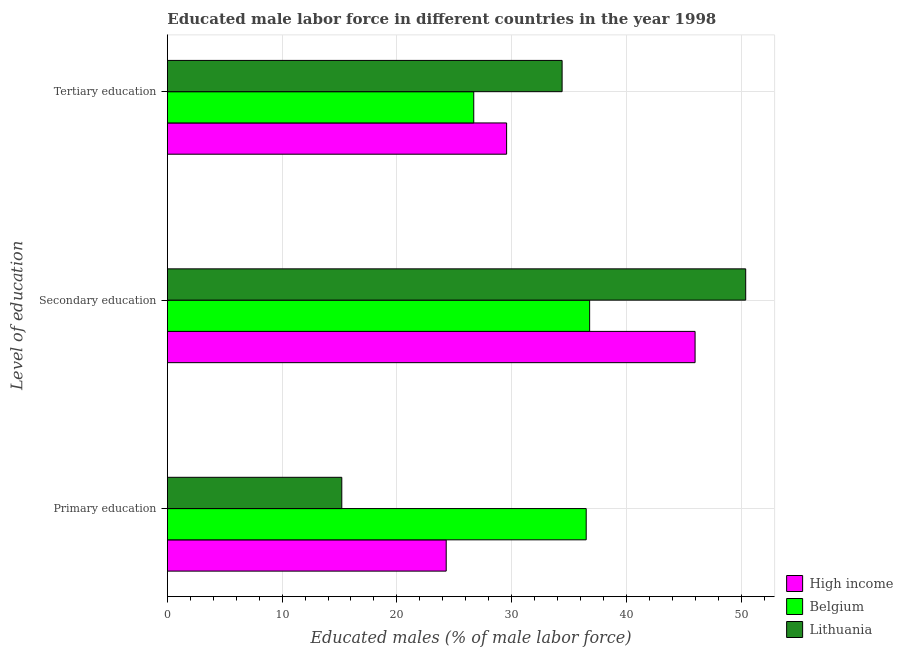Are the number of bars on each tick of the Y-axis equal?
Make the answer very short. Yes. How many bars are there on the 1st tick from the top?
Your answer should be very brief. 3. What is the label of the 2nd group of bars from the top?
Your response must be concise. Secondary education. What is the percentage of male labor force who received primary education in Lithuania?
Give a very brief answer. 15.2. Across all countries, what is the maximum percentage of male labor force who received primary education?
Your answer should be very brief. 36.5. Across all countries, what is the minimum percentage of male labor force who received tertiary education?
Give a very brief answer. 26.7. In which country was the percentage of male labor force who received primary education minimum?
Provide a succinct answer. Lithuania. What is the total percentage of male labor force who received tertiary education in the graph?
Your answer should be compact. 90.66. What is the difference between the percentage of male labor force who received tertiary education in High income and that in Belgium?
Make the answer very short. 2.86. What is the difference between the percentage of male labor force who received tertiary education in Lithuania and the percentage of male labor force who received primary education in Belgium?
Make the answer very short. -2.1. What is the average percentage of male labor force who received tertiary education per country?
Offer a very short reply. 30.22. What is the difference between the percentage of male labor force who received secondary education and percentage of male labor force who received tertiary education in High income?
Your response must be concise. 16.43. In how many countries, is the percentage of male labor force who received secondary education greater than 22 %?
Your answer should be compact. 3. What is the ratio of the percentage of male labor force who received secondary education in Belgium to that in Lithuania?
Give a very brief answer. 0.73. Is the percentage of male labor force who received primary education in High income less than that in Lithuania?
Your answer should be compact. No. Is the difference between the percentage of male labor force who received secondary education in Lithuania and Belgium greater than the difference between the percentage of male labor force who received tertiary education in Lithuania and Belgium?
Provide a succinct answer. Yes. What is the difference between the highest and the second highest percentage of male labor force who received primary education?
Make the answer very short. 12.2. What is the difference between the highest and the lowest percentage of male labor force who received tertiary education?
Keep it short and to the point. 7.7. Is the sum of the percentage of male labor force who received secondary education in Lithuania and High income greater than the maximum percentage of male labor force who received tertiary education across all countries?
Your response must be concise. Yes. What does the 1st bar from the top in Primary education represents?
Make the answer very short. Lithuania. What does the 2nd bar from the bottom in Tertiary education represents?
Your response must be concise. Belgium. Are all the bars in the graph horizontal?
Give a very brief answer. Yes. How many countries are there in the graph?
Give a very brief answer. 3. What is the difference between two consecutive major ticks on the X-axis?
Provide a short and direct response. 10. How many legend labels are there?
Ensure brevity in your answer.  3. What is the title of the graph?
Keep it short and to the point. Educated male labor force in different countries in the year 1998. Does "Russian Federation" appear as one of the legend labels in the graph?
Give a very brief answer. No. What is the label or title of the X-axis?
Your answer should be very brief. Educated males (% of male labor force). What is the label or title of the Y-axis?
Provide a succinct answer. Level of education. What is the Educated males (% of male labor force) of High income in Primary education?
Provide a short and direct response. 24.3. What is the Educated males (% of male labor force) of Belgium in Primary education?
Your response must be concise. 36.5. What is the Educated males (% of male labor force) in Lithuania in Primary education?
Your answer should be very brief. 15.2. What is the Educated males (% of male labor force) in High income in Secondary education?
Give a very brief answer. 45.99. What is the Educated males (% of male labor force) of Belgium in Secondary education?
Make the answer very short. 36.8. What is the Educated males (% of male labor force) of Lithuania in Secondary education?
Offer a very short reply. 50.4. What is the Educated males (% of male labor force) of High income in Tertiary education?
Offer a very short reply. 29.56. What is the Educated males (% of male labor force) of Belgium in Tertiary education?
Keep it short and to the point. 26.7. What is the Educated males (% of male labor force) of Lithuania in Tertiary education?
Your answer should be very brief. 34.4. Across all Level of education, what is the maximum Educated males (% of male labor force) in High income?
Your response must be concise. 45.99. Across all Level of education, what is the maximum Educated males (% of male labor force) of Belgium?
Make the answer very short. 36.8. Across all Level of education, what is the maximum Educated males (% of male labor force) of Lithuania?
Ensure brevity in your answer.  50.4. Across all Level of education, what is the minimum Educated males (% of male labor force) of High income?
Your response must be concise. 24.3. Across all Level of education, what is the minimum Educated males (% of male labor force) of Belgium?
Provide a short and direct response. 26.7. Across all Level of education, what is the minimum Educated males (% of male labor force) of Lithuania?
Provide a short and direct response. 15.2. What is the total Educated males (% of male labor force) in High income in the graph?
Give a very brief answer. 99.85. What is the difference between the Educated males (% of male labor force) of High income in Primary education and that in Secondary education?
Keep it short and to the point. -21.69. What is the difference between the Educated males (% of male labor force) in Belgium in Primary education and that in Secondary education?
Make the answer very short. -0.3. What is the difference between the Educated males (% of male labor force) in Lithuania in Primary education and that in Secondary education?
Your answer should be compact. -35.2. What is the difference between the Educated males (% of male labor force) of High income in Primary education and that in Tertiary education?
Offer a terse response. -5.26. What is the difference between the Educated males (% of male labor force) of Belgium in Primary education and that in Tertiary education?
Your response must be concise. 9.8. What is the difference between the Educated males (% of male labor force) in Lithuania in Primary education and that in Tertiary education?
Your answer should be compact. -19.2. What is the difference between the Educated males (% of male labor force) of High income in Secondary education and that in Tertiary education?
Your answer should be compact. 16.43. What is the difference between the Educated males (% of male labor force) in Belgium in Secondary education and that in Tertiary education?
Provide a short and direct response. 10.1. What is the difference between the Educated males (% of male labor force) of Lithuania in Secondary education and that in Tertiary education?
Your answer should be compact. 16. What is the difference between the Educated males (% of male labor force) in High income in Primary education and the Educated males (% of male labor force) in Belgium in Secondary education?
Offer a very short reply. -12.5. What is the difference between the Educated males (% of male labor force) in High income in Primary education and the Educated males (% of male labor force) in Lithuania in Secondary education?
Offer a terse response. -26.1. What is the difference between the Educated males (% of male labor force) of High income in Primary education and the Educated males (% of male labor force) of Belgium in Tertiary education?
Provide a short and direct response. -2.4. What is the difference between the Educated males (% of male labor force) in High income in Primary education and the Educated males (% of male labor force) in Lithuania in Tertiary education?
Ensure brevity in your answer.  -10.1. What is the difference between the Educated males (% of male labor force) of Belgium in Primary education and the Educated males (% of male labor force) of Lithuania in Tertiary education?
Give a very brief answer. 2.1. What is the difference between the Educated males (% of male labor force) of High income in Secondary education and the Educated males (% of male labor force) of Belgium in Tertiary education?
Offer a very short reply. 19.29. What is the difference between the Educated males (% of male labor force) in High income in Secondary education and the Educated males (% of male labor force) in Lithuania in Tertiary education?
Your response must be concise. 11.59. What is the difference between the Educated males (% of male labor force) in Belgium in Secondary education and the Educated males (% of male labor force) in Lithuania in Tertiary education?
Make the answer very short. 2.4. What is the average Educated males (% of male labor force) in High income per Level of education?
Give a very brief answer. 33.28. What is the average Educated males (% of male labor force) in Belgium per Level of education?
Your answer should be very brief. 33.33. What is the average Educated males (% of male labor force) in Lithuania per Level of education?
Offer a terse response. 33.33. What is the difference between the Educated males (% of male labor force) of High income and Educated males (% of male labor force) of Belgium in Primary education?
Keep it short and to the point. -12.2. What is the difference between the Educated males (% of male labor force) in High income and Educated males (% of male labor force) in Lithuania in Primary education?
Provide a succinct answer. 9.1. What is the difference between the Educated males (% of male labor force) in Belgium and Educated males (% of male labor force) in Lithuania in Primary education?
Offer a very short reply. 21.3. What is the difference between the Educated males (% of male labor force) in High income and Educated males (% of male labor force) in Belgium in Secondary education?
Ensure brevity in your answer.  9.19. What is the difference between the Educated males (% of male labor force) in High income and Educated males (% of male labor force) in Lithuania in Secondary education?
Keep it short and to the point. -4.41. What is the difference between the Educated males (% of male labor force) of Belgium and Educated males (% of male labor force) of Lithuania in Secondary education?
Make the answer very short. -13.6. What is the difference between the Educated males (% of male labor force) in High income and Educated males (% of male labor force) in Belgium in Tertiary education?
Offer a terse response. 2.86. What is the difference between the Educated males (% of male labor force) in High income and Educated males (% of male labor force) in Lithuania in Tertiary education?
Provide a short and direct response. -4.84. What is the difference between the Educated males (% of male labor force) in Belgium and Educated males (% of male labor force) in Lithuania in Tertiary education?
Offer a terse response. -7.7. What is the ratio of the Educated males (% of male labor force) in High income in Primary education to that in Secondary education?
Provide a short and direct response. 0.53. What is the ratio of the Educated males (% of male labor force) in Belgium in Primary education to that in Secondary education?
Ensure brevity in your answer.  0.99. What is the ratio of the Educated males (% of male labor force) in Lithuania in Primary education to that in Secondary education?
Offer a very short reply. 0.3. What is the ratio of the Educated males (% of male labor force) of High income in Primary education to that in Tertiary education?
Offer a terse response. 0.82. What is the ratio of the Educated males (% of male labor force) in Belgium in Primary education to that in Tertiary education?
Your answer should be very brief. 1.37. What is the ratio of the Educated males (% of male labor force) of Lithuania in Primary education to that in Tertiary education?
Provide a short and direct response. 0.44. What is the ratio of the Educated males (% of male labor force) in High income in Secondary education to that in Tertiary education?
Keep it short and to the point. 1.56. What is the ratio of the Educated males (% of male labor force) in Belgium in Secondary education to that in Tertiary education?
Ensure brevity in your answer.  1.38. What is the ratio of the Educated males (% of male labor force) of Lithuania in Secondary education to that in Tertiary education?
Provide a short and direct response. 1.47. What is the difference between the highest and the second highest Educated males (% of male labor force) of High income?
Offer a terse response. 16.43. What is the difference between the highest and the lowest Educated males (% of male labor force) of High income?
Your answer should be compact. 21.69. What is the difference between the highest and the lowest Educated males (% of male labor force) of Belgium?
Your answer should be compact. 10.1. What is the difference between the highest and the lowest Educated males (% of male labor force) in Lithuania?
Your answer should be very brief. 35.2. 